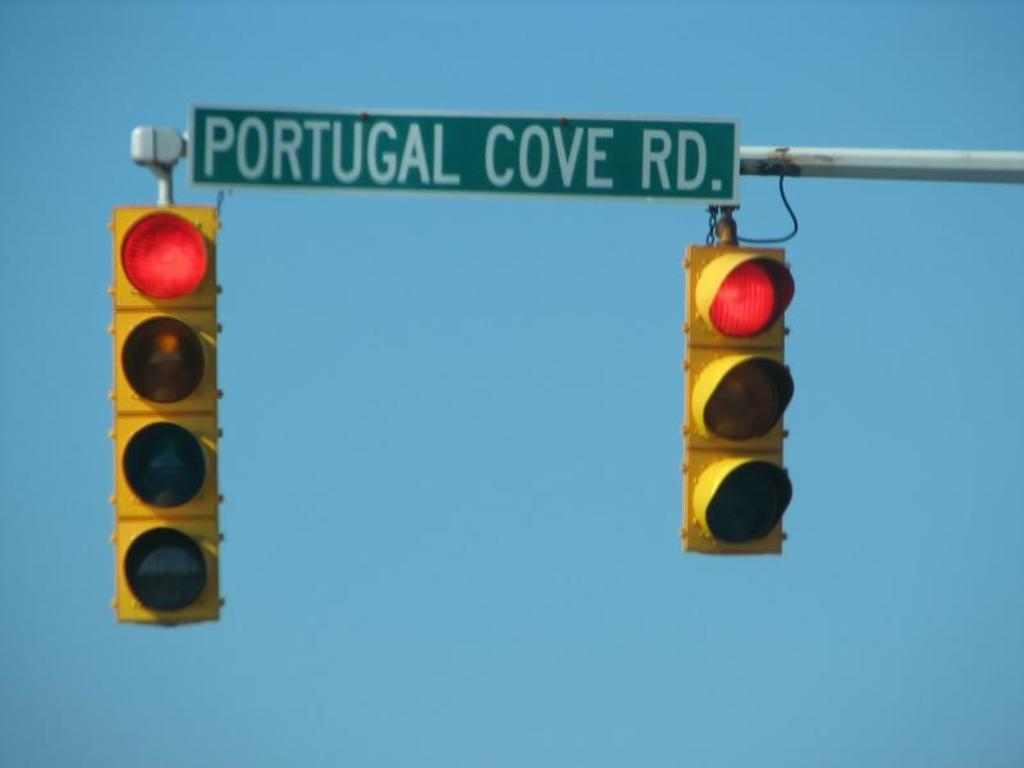<image>
Provide a brief description of the given image. some traffic lights that are below a portugal sign 